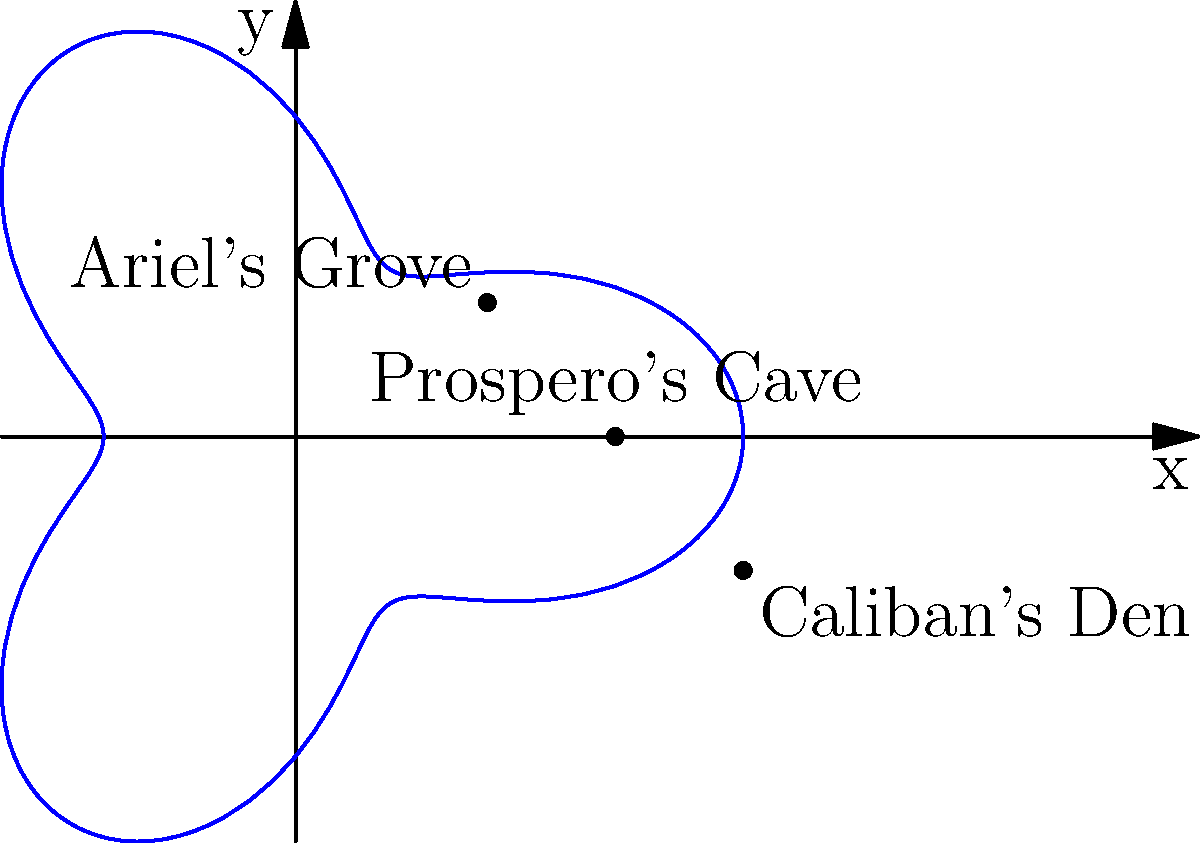In Shakespeare's "The Tempest," the island is represented by the polar curve $r = 5 + 2\cos(3\theta)$. If Prospero starts at his cave $(5,0)$ and travels counterclockwise along the curve to reach Ariel's Grove, what is the polar angle $\theta$ (in radians) of Ariel's Grove? To solve this problem, we need to follow these steps:

1) The given polar curve equation is $r = 5 + 2\cos(3\theta)$.

2) We're told that Prospero starts at $(5,0)$, which in polar coordinates is $(r,\theta) = (5,0)$.

3) The question states that Ariel's Grove is reached by traveling counterclockwise along the curve.

4) Looking at the polar graph, we can see that one complete "petal" of the curve occurs every $\frac{2\pi}{3}$ radians due to the $3\theta$ term in the cosine function.

5) Ariel's Grove appears to be at the tip of the first petal encountered when moving counterclockwise from Prospero's Cave.

6) Therefore, the polar angle $\theta$ for Ariel's Grove must be $\frac{2\pi}{3}$ radians.

7) We can verify this by plugging $\theta = \frac{2\pi}{3}$ into the equation:

   $r = 5 + 2\cos(3 \cdot \frac{2\pi}{3}) = 5 + 2\cos(2\pi) = 5 + 2 = 7$

   This matches the location of Ariel's Grove on the graph.
Answer: $\frac{2\pi}{3}$ radians 